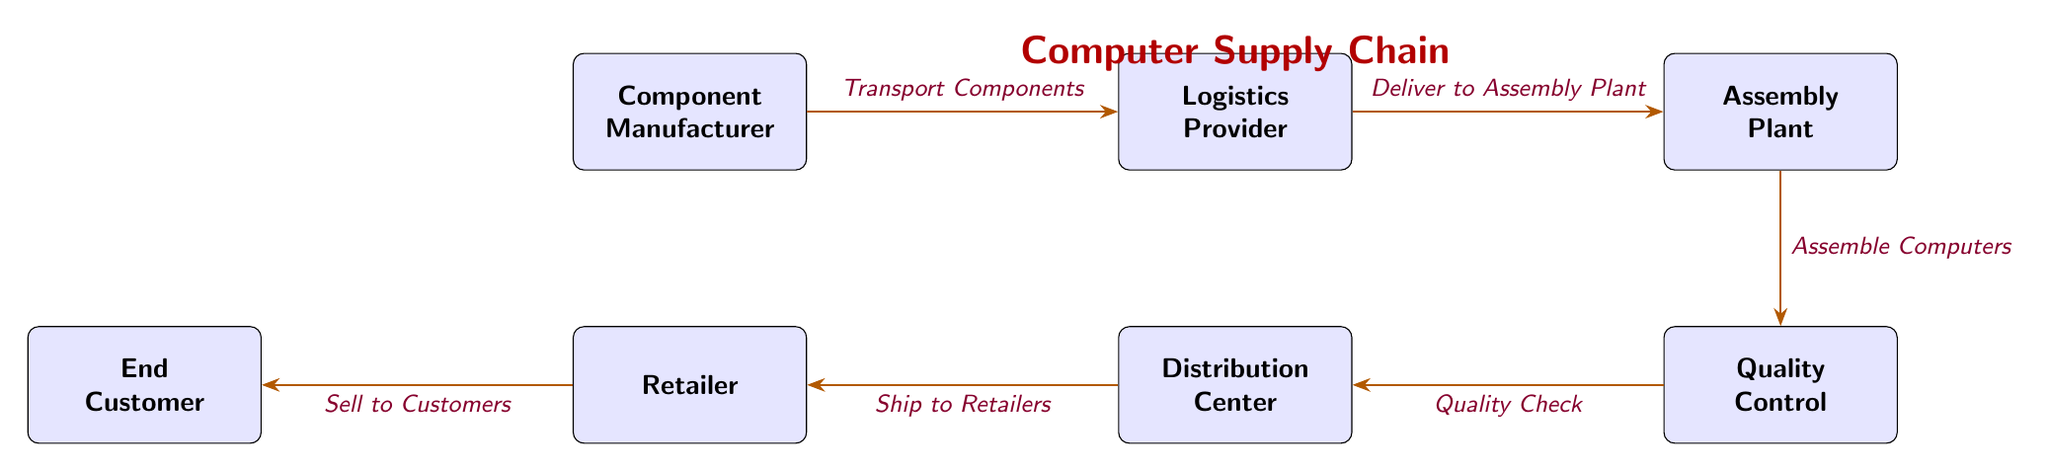How many nodes are in the diagram? The diagram contains six distinct boxes representing different stages in the supply chain: Component Manufacturer, Logistics Provider, Assembly Plant, Quality Control, Distribution Center, Retailer, and End Customer. Counting these, we find a total of six nodes.
Answer: 6 What is the first step in the supply chain? The first node in the supply chain is the Component Manufacturer, which is the starting point for this process.
Answer: Component Manufacturer What flows from the Logistics Provider to the Assembly Plant? The arrow connecting Logistics Provider and Assembly Plant indicates that components are transported from the Logistics Provider to the Assembly Plant, represented by the label "Deliver to Assembly Plant."
Answer: Deliver to Assembly Plant Which stage occurs after Quality Control? After the Quality Control stage, the next stage is the Distribution Center, as indicated by the arrow leading from Quality Control to Distribution Center.
Answer: Distribution Center What is the final stage before the end customer? The Retailer stage is the step right before reaching the end customer, as shown by the arrow that moves from Distribution Center to Retailer.
Answer: Retailer How are computers assembled according to the diagram? According to the diagram, computers are assembled in the Assembly Plant stage, as shown by the specific label "Assemble Computers" leading from Assembly Plant to Quality Control.
Answer: Assemble Computers Which connection does occur between Distribution Center and Retailer? The arrow from Distribution Center to Retailer shows that the Distribution Center ships products to the Retailer, as indicated by the label "Ship to Retailers."
Answer: Ship to Retailers What is the role of the Quality Control stage? The Quality Control stage serves to perform a quality check on the assembled computers before they are distributed, as described by the flow from Assembly Plant to Distribution Center labeled "Quality Check."
Answer: Quality Check What is transported from the Component Manufacturer to Logistics Provider? The flow from the Component Manufacturer to the Logistics Provider is described by the label "Transport Components," indicating that components are transported between these two nodes.
Answer: Transport Components 